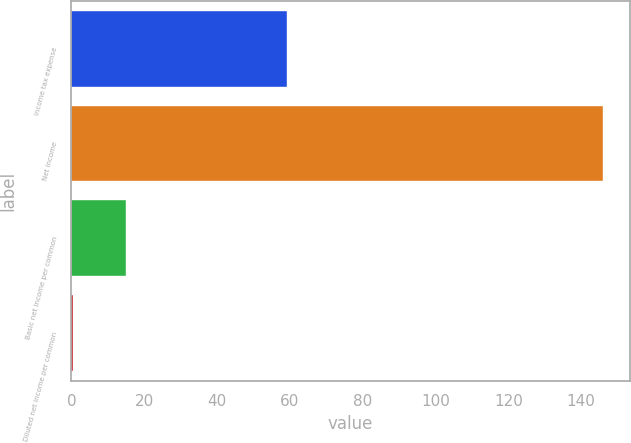Convert chart to OTSL. <chart><loc_0><loc_0><loc_500><loc_500><bar_chart><fcel>Income tax expense<fcel>Net income<fcel>Basic net income per common<fcel>Diluted net income per common<nl><fcel>59.1<fcel>146<fcel>14.98<fcel>0.42<nl></chart> 